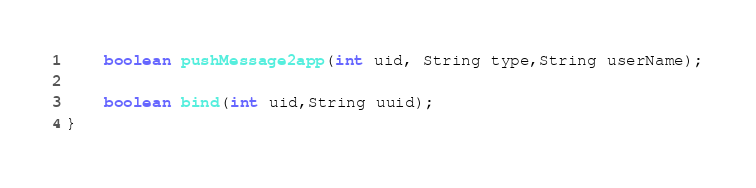Convert code to text. <code><loc_0><loc_0><loc_500><loc_500><_Java_>    boolean pushMessage2app(int uid, String type,String userName);

    boolean bind(int uid,String uuid);
}
</code> 